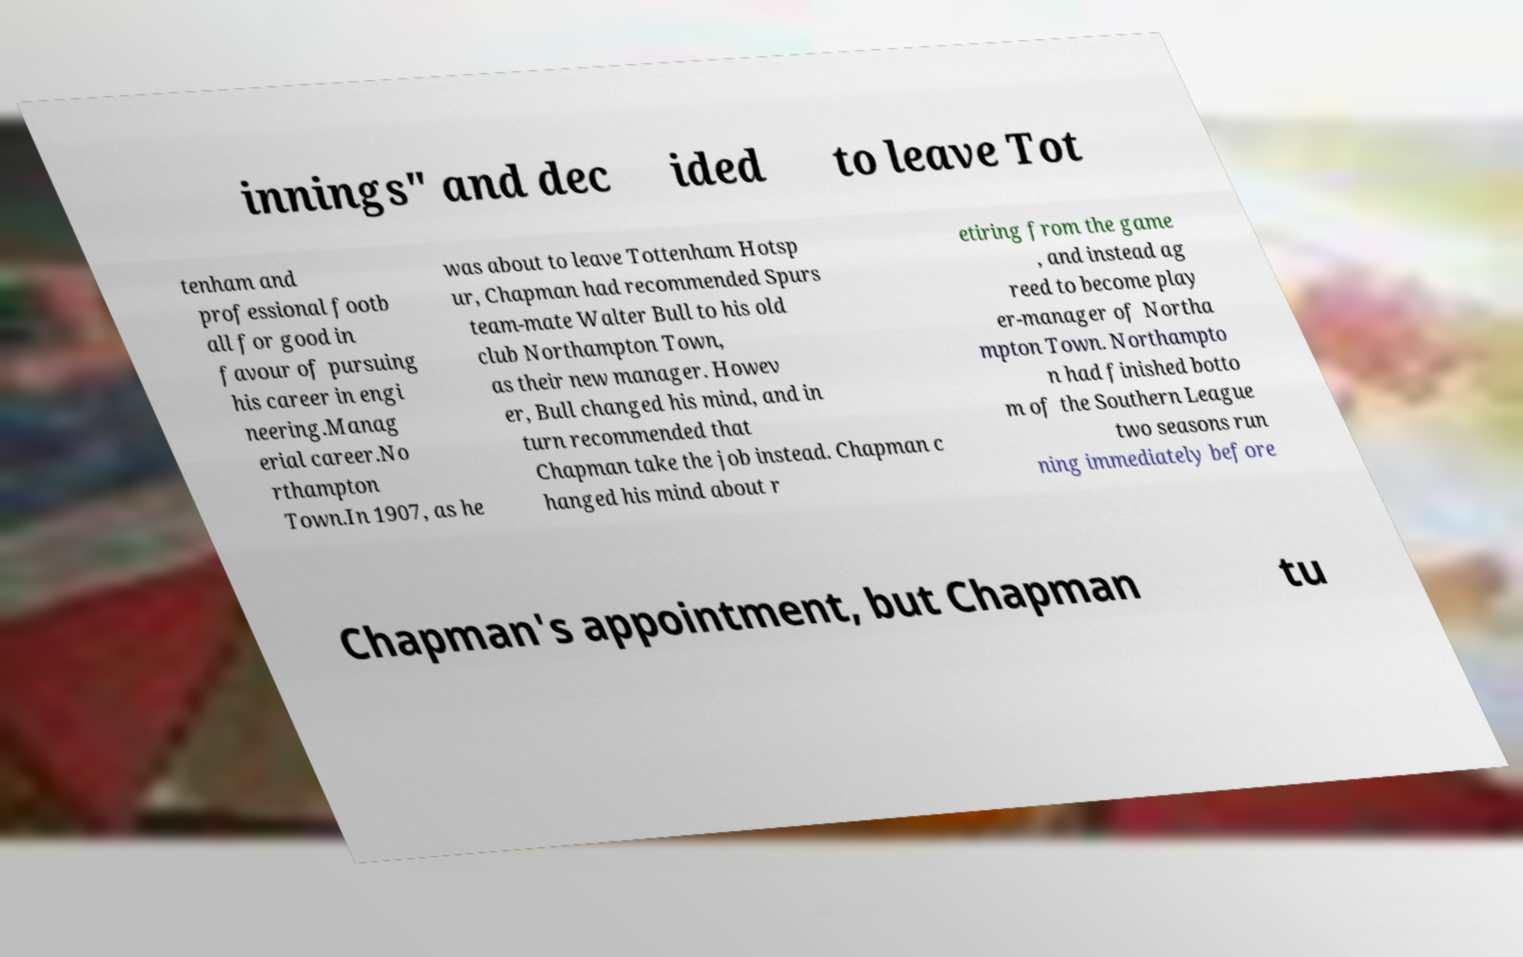For documentation purposes, I need the text within this image transcribed. Could you provide that? innings" and dec ided to leave Tot tenham and professional footb all for good in favour of pursuing his career in engi neering.Manag erial career.No rthampton Town.In 1907, as he was about to leave Tottenham Hotsp ur, Chapman had recommended Spurs team-mate Walter Bull to his old club Northampton Town, as their new manager. Howev er, Bull changed his mind, and in turn recommended that Chapman take the job instead. Chapman c hanged his mind about r etiring from the game , and instead ag reed to become play er-manager of Northa mpton Town. Northampto n had finished botto m of the Southern League two seasons run ning immediately before Chapman's appointment, but Chapman tu 